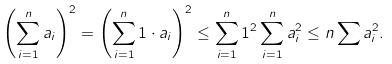<formula> <loc_0><loc_0><loc_500><loc_500>\left ( \sum _ { i = 1 } ^ { n } a _ { i } \right ) ^ { 2 } = \left ( \sum _ { i = 1 } ^ { n } 1 \cdot a _ { i } \right ) ^ { 2 } \leq \sum _ { i = 1 } ^ { n } 1 ^ { 2 } \sum _ { i = 1 } ^ { n } a _ { i } ^ { 2 } \leq n \sum a _ { i } ^ { 2 } .</formula> 